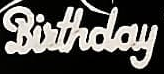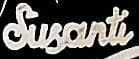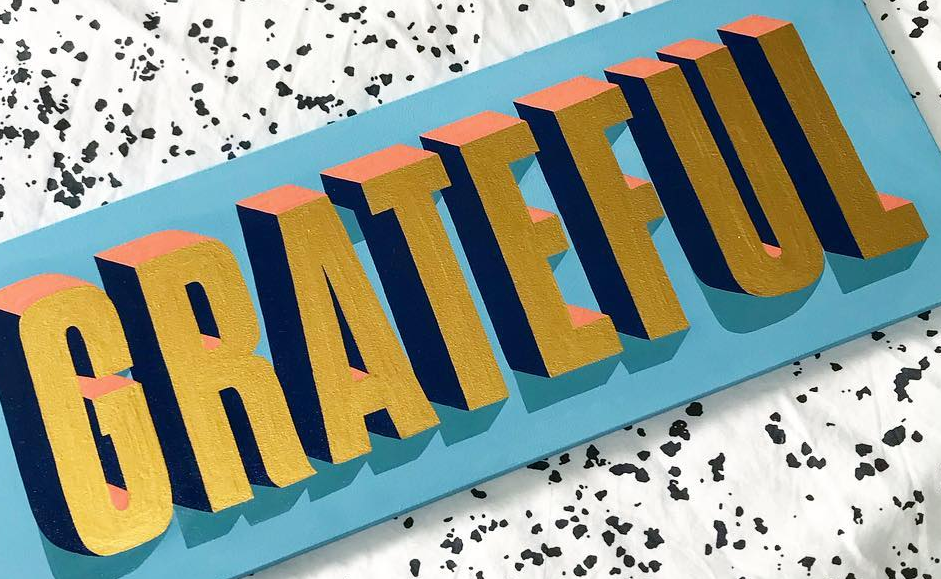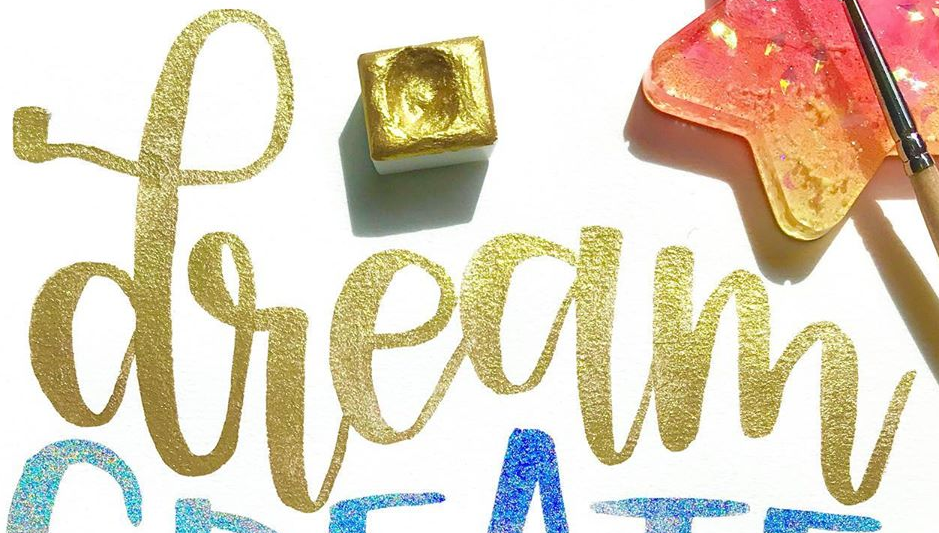Read the text content from these images in order, separated by a semicolon. Birthday; Susanti; GRATEFUL; dream 